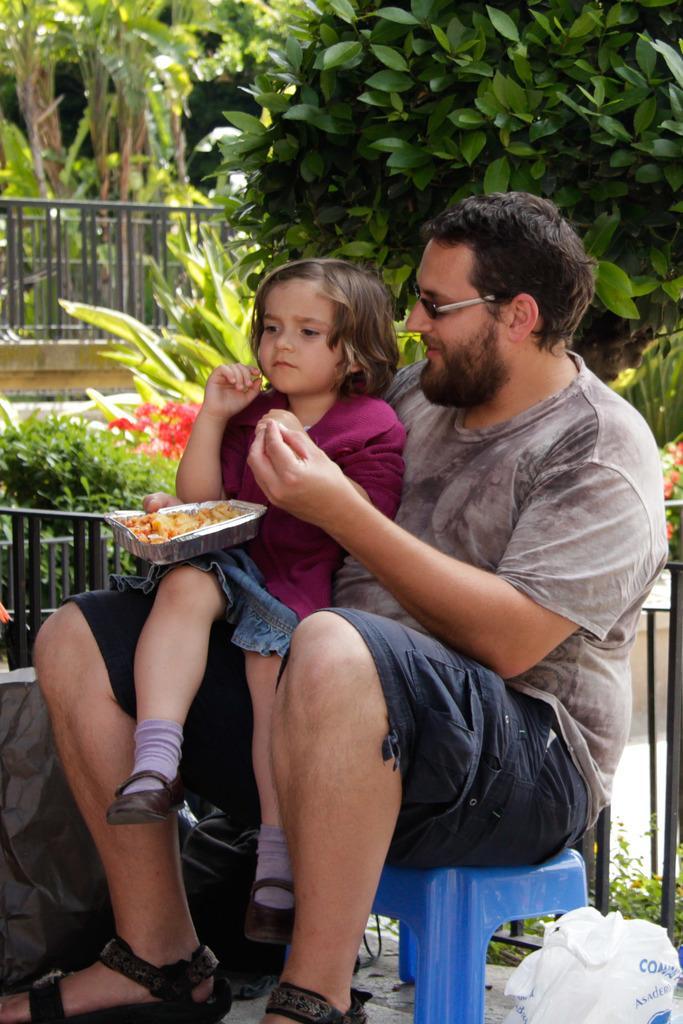How would you summarize this image in a sentence or two? In this picture there is a man sitting on the stool and he is holding the box, there is a food in the box. There is a girl sitting on the man. At the back there are trees and flowers. At the bottom there is a cover. 